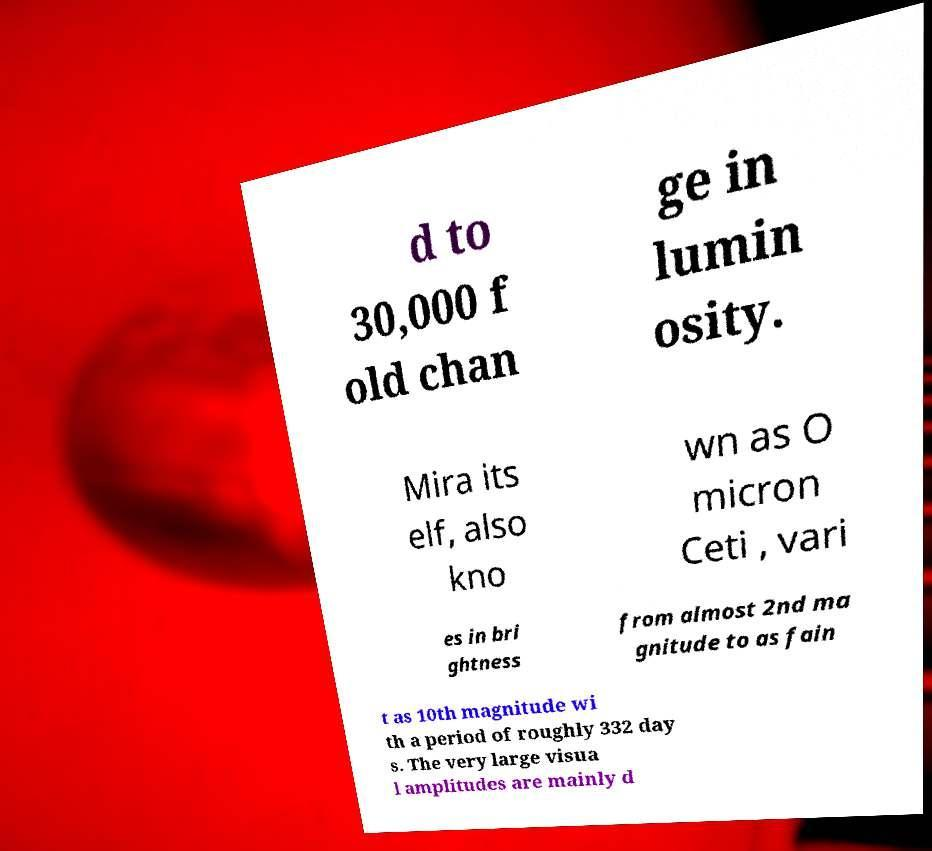Could you extract and type out the text from this image? d to 30,000 f old chan ge in lumin osity. Mira its elf, also kno wn as O micron Ceti , vari es in bri ghtness from almost 2nd ma gnitude to as fain t as 10th magnitude wi th a period of roughly 332 day s. The very large visua l amplitudes are mainly d 